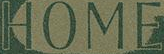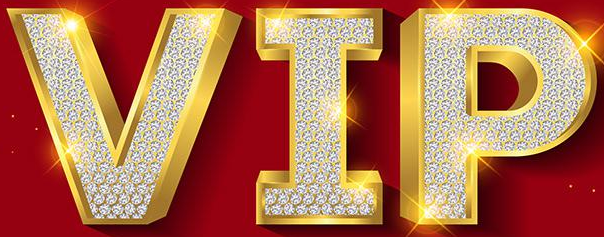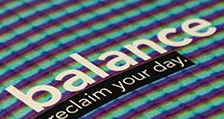What words are shown in these images in order, separated by a semicolon? HOME; VIP; balance 